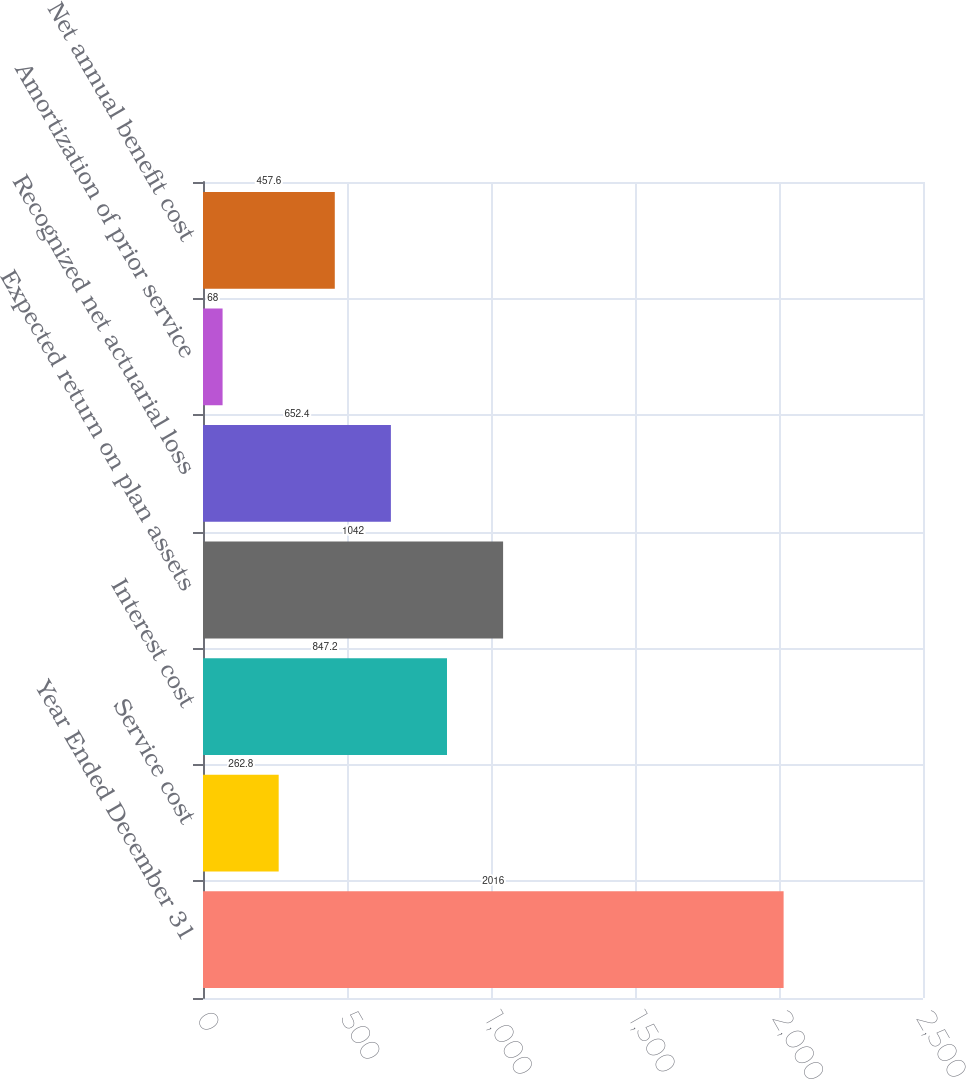Convert chart to OTSL. <chart><loc_0><loc_0><loc_500><loc_500><bar_chart><fcel>Year Ended December 31<fcel>Service cost<fcel>Interest cost<fcel>Expected return on plan assets<fcel>Recognized net actuarial loss<fcel>Amortization of prior service<fcel>Net annual benefit cost<nl><fcel>2016<fcel>262.8<fcel>847.2<fcel>1042<fcel>652.4<fcel>68<fcel>457.6<nl></chart> 